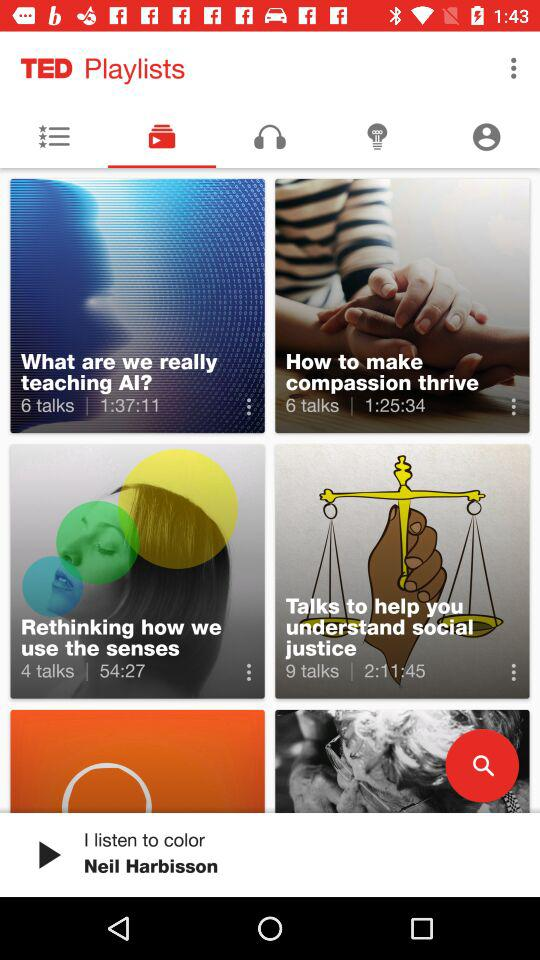What is the duration of the "What are we really teaching AI" playlist? The duration is 1 hour, 6 minutes and 11 seconds. 